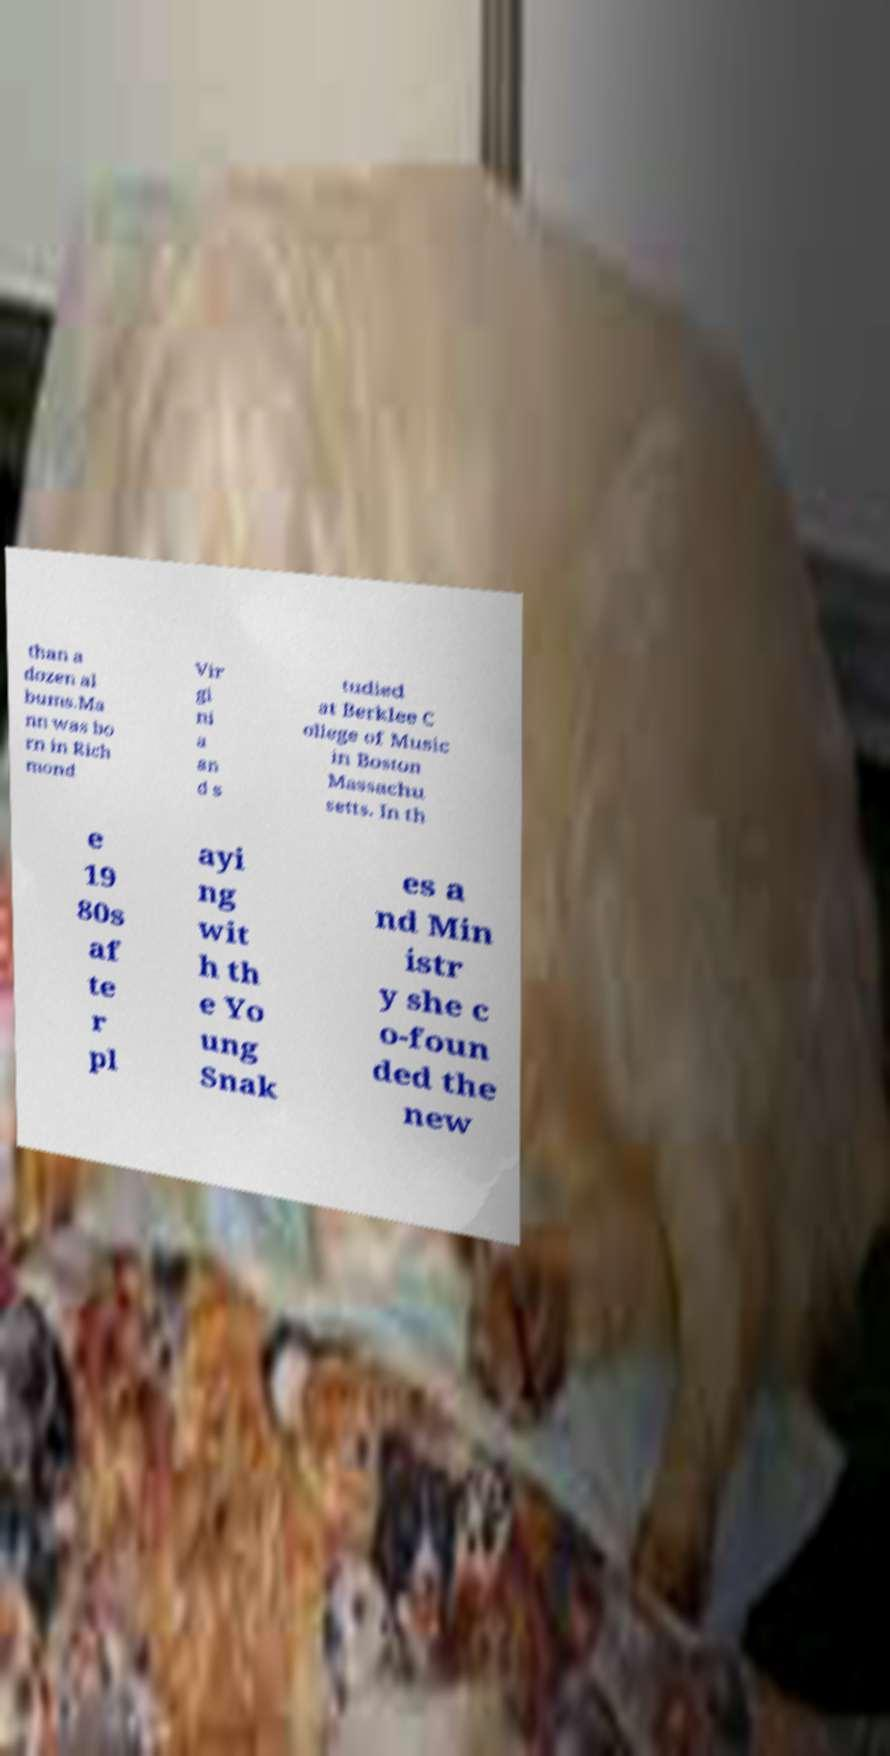Please read and relay the text visible in this image. What does it say? than a dozen al bums.Ma nn was bo rn in Rich mond Vir gi ni a an d s tudied at Berklee C ollege of Music in Boston Massachu setts. In th e 19 80s af te r pl ayi ng wit h th e Yo ung Snak es a nd Min istr y she c o-foun ded the new 